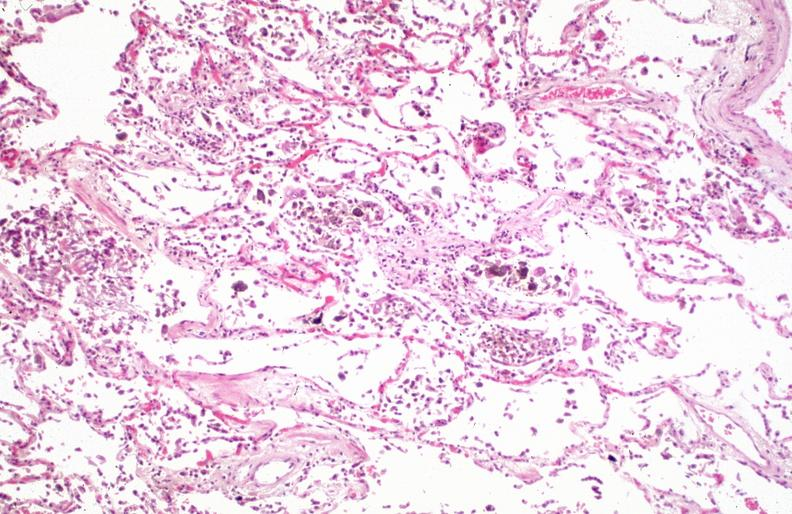what is present?
Answer the question using a single word or phrase. Respiratory 